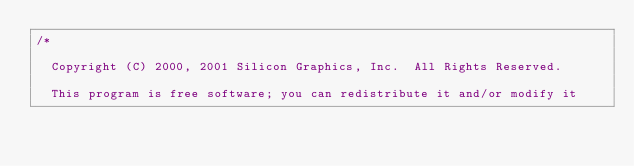Convert code to text. <code><loc_0><loc_0><loc_500><loc_500><_C_>/*

  Copyright (C) 2000, 2001 Silicon Graphics, Inc.  All Rights Reserved.

  This program is free software; you can redistribute it and/or modify it</code> 